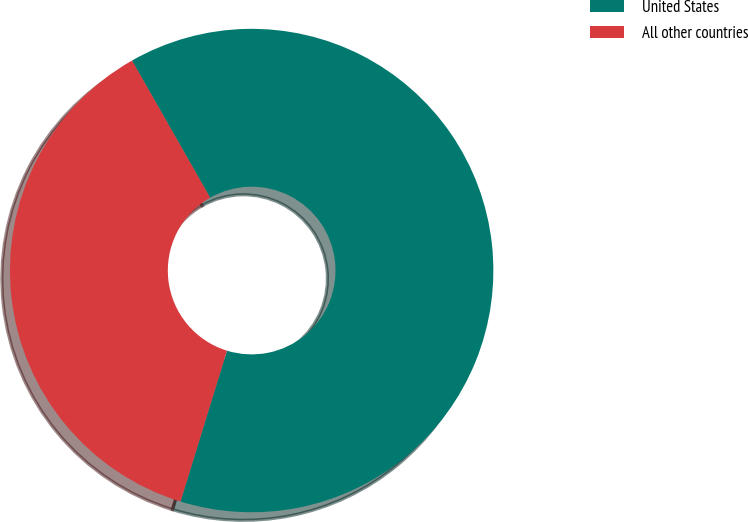Convert chart to OTSL. <chart><loc_0><loc_0><loc_500><loc_500><pie_chart><fcel>United States<fcel>All other countries<nl><fcel>63.0%<fcel>37.0%<nl></chart> 